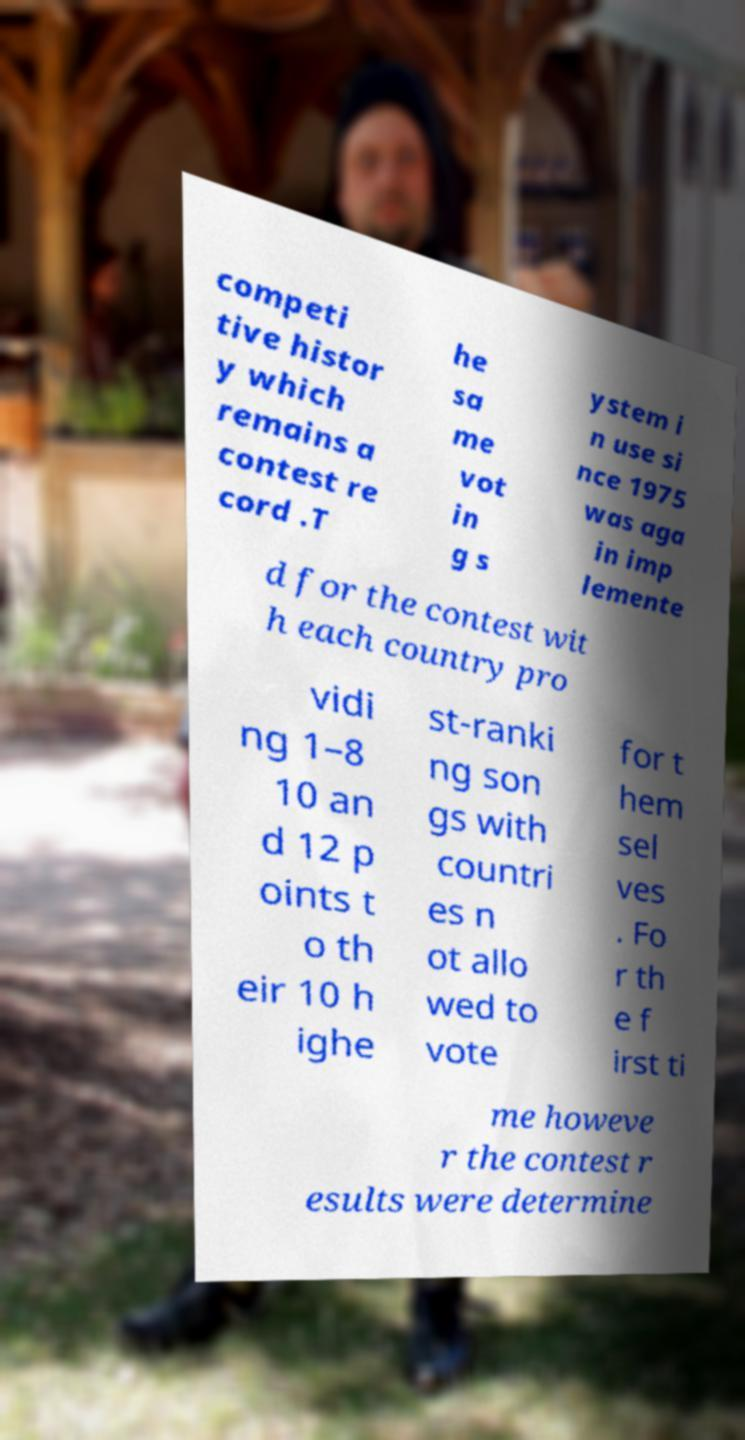Could you assist in decoding the text presented in this image and type it out clearly? competi tive histor y which remains a contest re cord .T he sa me vot in g s ystem i n use si nce 1975 was aga in imp lemente d for the contest wit h each country pro vidi ng 1–8 10 an d 12 p oints t o th eir 10 h ighe st-ranki ng son gs with countri es n ot allo wed to vote for t hem sel ves . Fo r th e f irst ti me howeve r the contest r esults were determine 